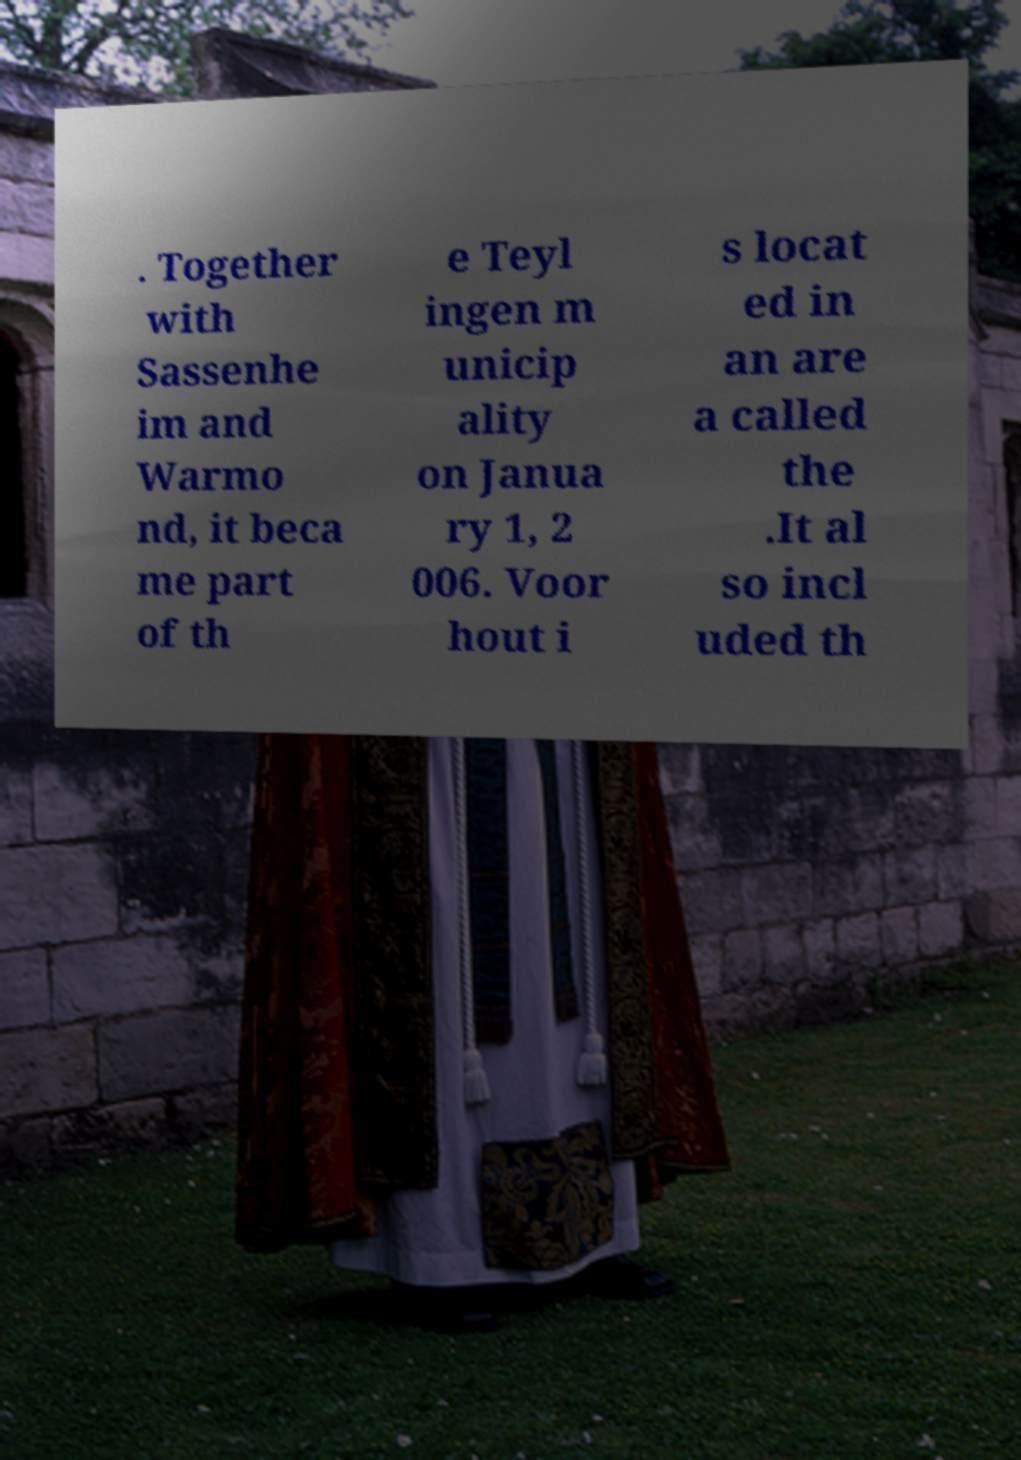Could you assist in decoding the text presented in this image and type it out clearly? . Together with Sassenhe im and Warmo nd, it beca me part of th e Teyl ingen m unicip ality on Janua ry 1, 2 006. Voor hout i s locat ed in an are a called the .It al so incl uded th 